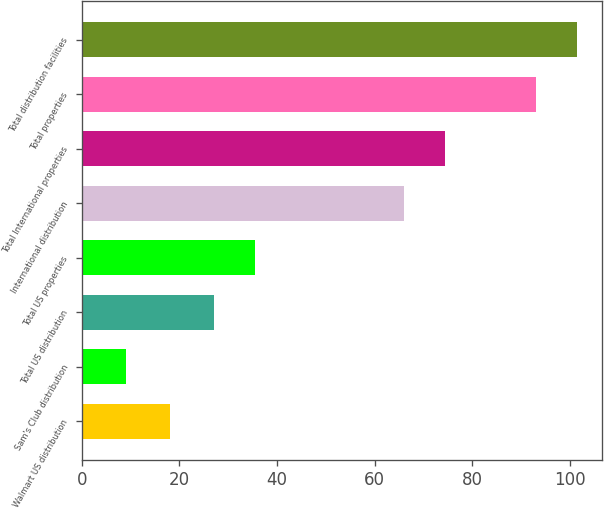Convert chart. <chart><loc_0><loc_0><loc_500><loc_500><bar_chart><fcel>Walmart US distribution<fcel>Sam's Club distribution<fcel>Total US distribution<fcel>Total US properties<fcel>International distribution<fcel>Total International properties<fcel>Total properties<fcel>Total distribution facilities<nl><fcel>18<fcel>9<fcel>27<fcel>35.4<fcel>66<fcel>74.4<fcel>93<fcel>101.4<nl></chart> 